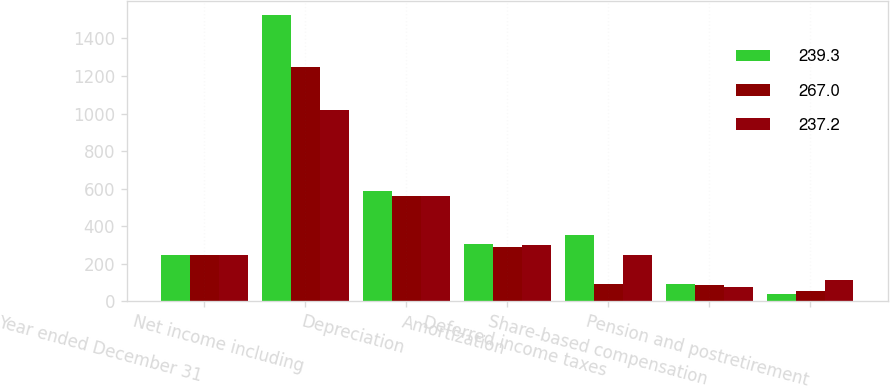Convert chart. <chart><loc_0><loc_0><loc_500><loc_500><stacked_bar_chart><ecel><fcel>Year ended December 31<fcel>Net income including<fcel>Depreciation<fcel>Amortization<fcel>Deferred income taxes<fcel>Share-based compensation<fcel>Pension and postretirement<nl><fcel>239.3<fcel>244.5<fcel>1522.4<fcel>585.7<fcel>307.6<fcel>354.5<fcel>90.5<fcel>36.9<nl><fcel>267<fcel>244.5<fcel>1247.1<fcel>561<fcel>289.7<fcel>90.6<fcel>85.7<fcel>54.1<nl><fcel>237.2<fcel>244.5<fcel>1017.2<fcel>559.5<fcel>300<fcel>244.5<fcel>78.2<fcel>113.8<nl></chart> 